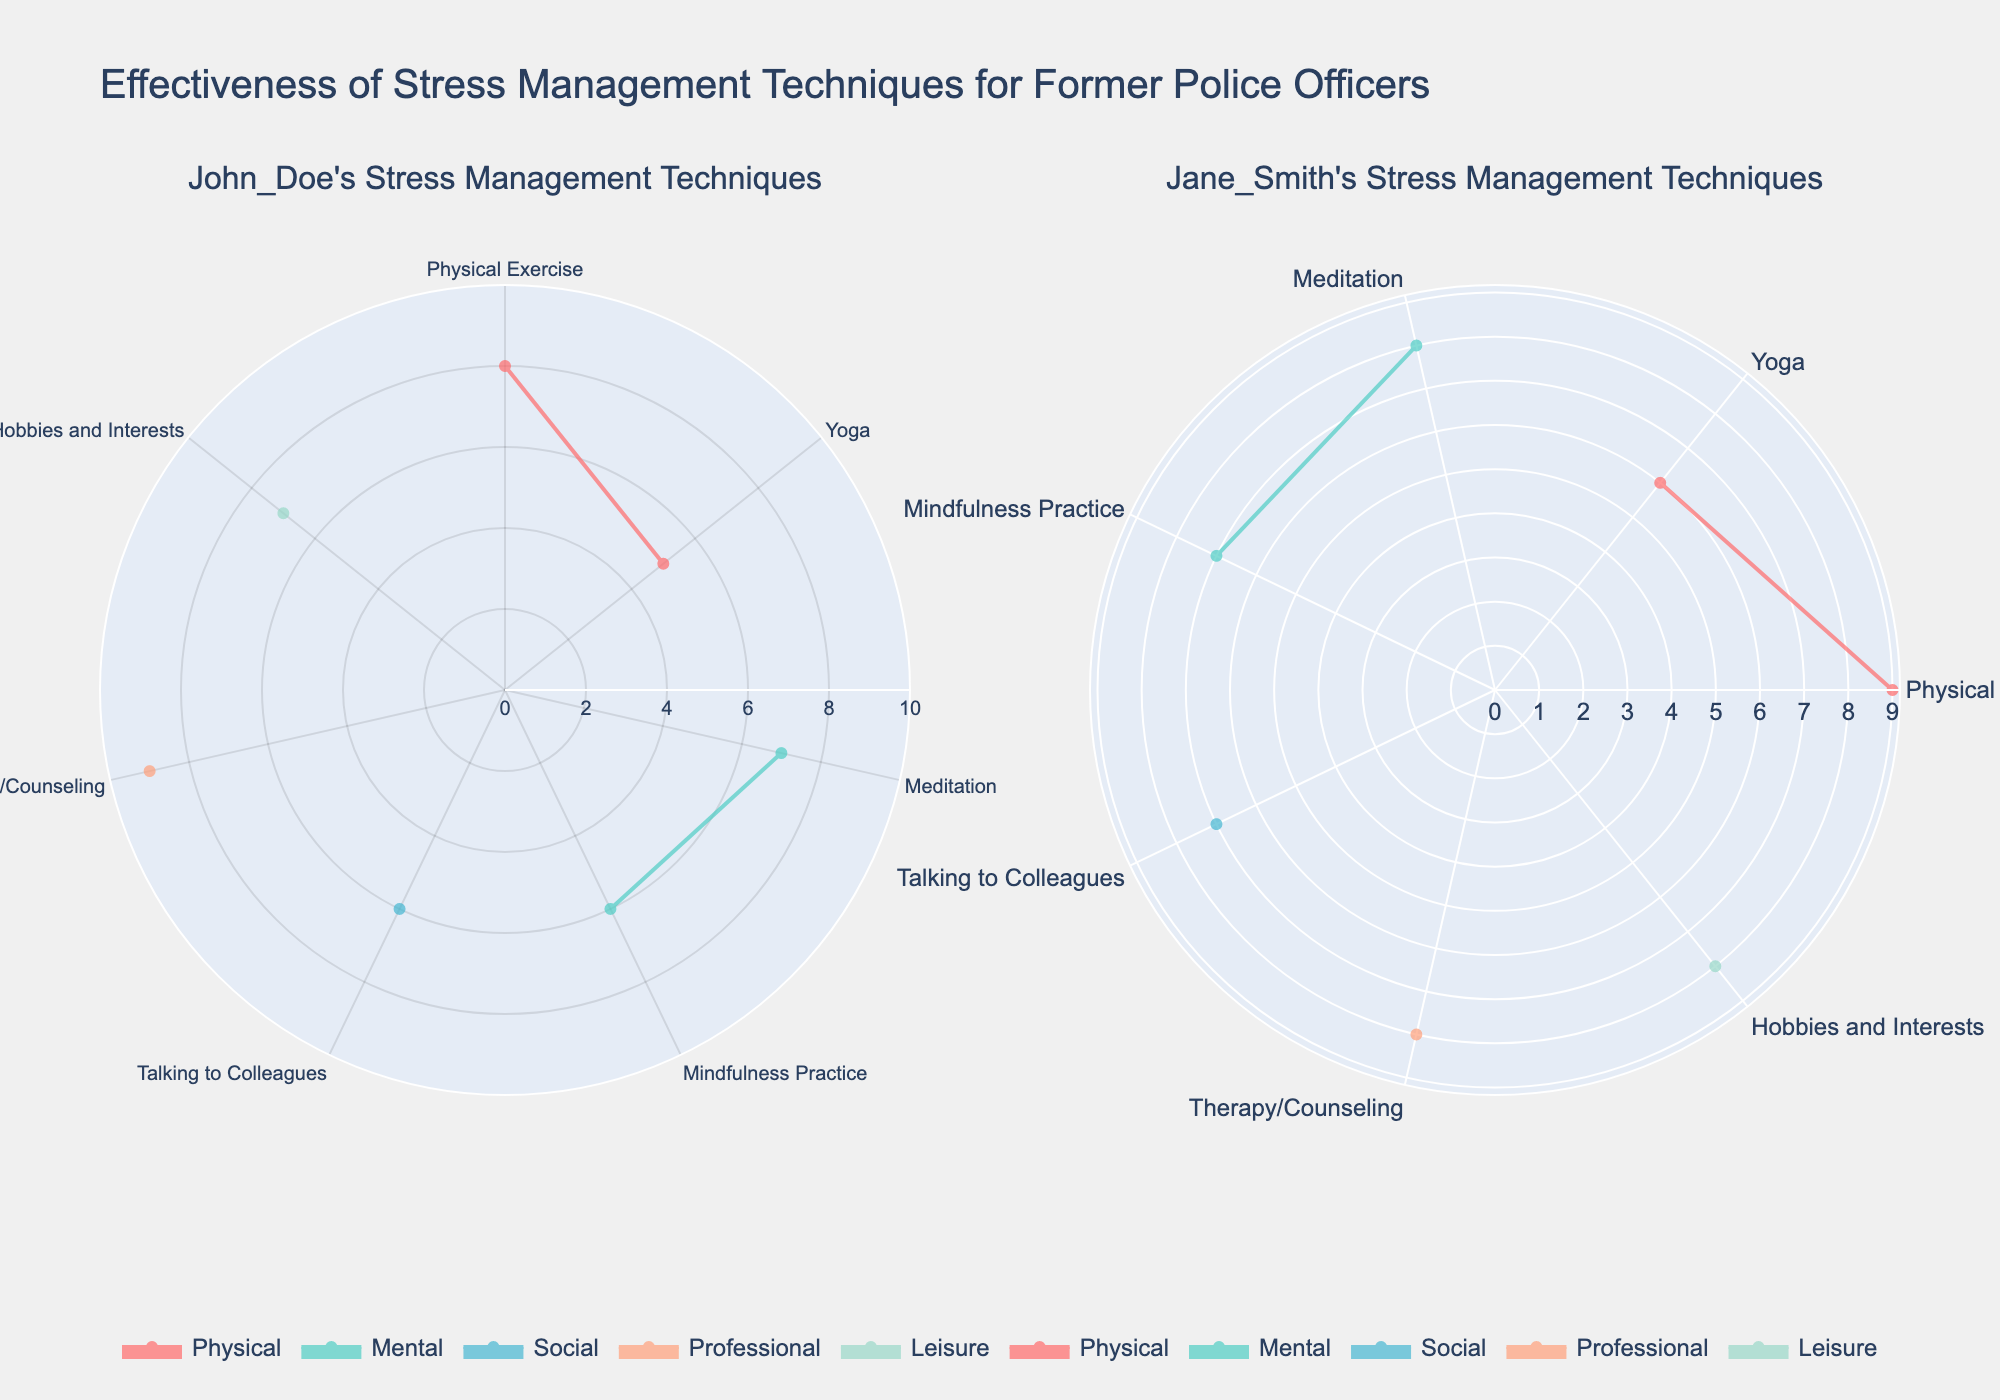What is the effectiveness score for Physical Exercise by John Doe? Look at John Doe's polar chart and note the score corresponding to Physical Exercise.
Answer: 8 What technique is rated the lowest by Jane Smith? Look at Jane Smith's polar chart and identify the technique with the lowest effectiveness score.
Answer: Yoga Which category does Meditation fall under for John Doe? Check John Doe's polar chart and locate Meditation, then note its corresponding category.
Answer: Mental How many techniques are included under the Social category for Jane Smith? Count the techniques categorized under Social from Jane Smith's polar chart.
Answer: 1 Which technique has the highest effectiveness score for John Doe? Examine John Doe's polar chart to determine which technique has the highest rating.
Answer: Therapy/Counseling Compare the effectiveness scores of Meditation and Yoga for Jane Smith. Which one is higher? Look at Jane Smith's polar chart, compare the scores for Meditation and Yoga, and identify which is higher.
Answer: Meditation Calculate the average effectiveness score for Professional category techniques for both officers. Sum the effectiveness scores for Therapy/Counseling for both John Doe and Jane Smith, then divide by 2. Calculation: (9 + 8) / 2 = 8.5
Answer: 8.5 What is the title of the overall plot? Read the title at the top of the polar chart figure.
Answer: Effectiveness of Stress Management Techniques for Former Police Officers Which category uses turquoise color? Identify the categories on the polar chart legend and associate the color turquoise with its category.
Answer: Physical Determine the range indicated on the radial axis for the polar charts. Check the radial axis' tick marks range on both subplots.
Answer: 0 to 10 